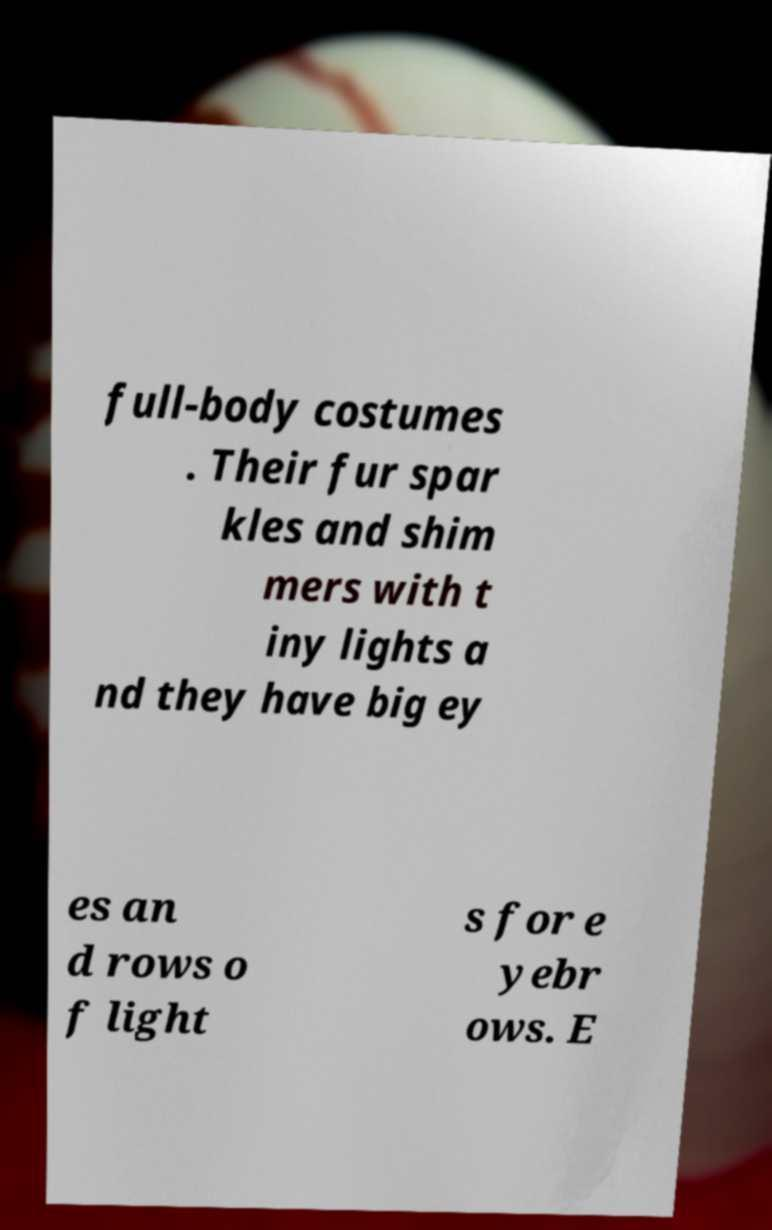Can you read and provide the text displayed in the image?This photo seems to have some interesting text. Can you extract and type it out for me? full-body costumes . Their fur spar kles and shim mers with t iny lights a nd they have big ey es an d rows o f light s for e yebr ows. E 